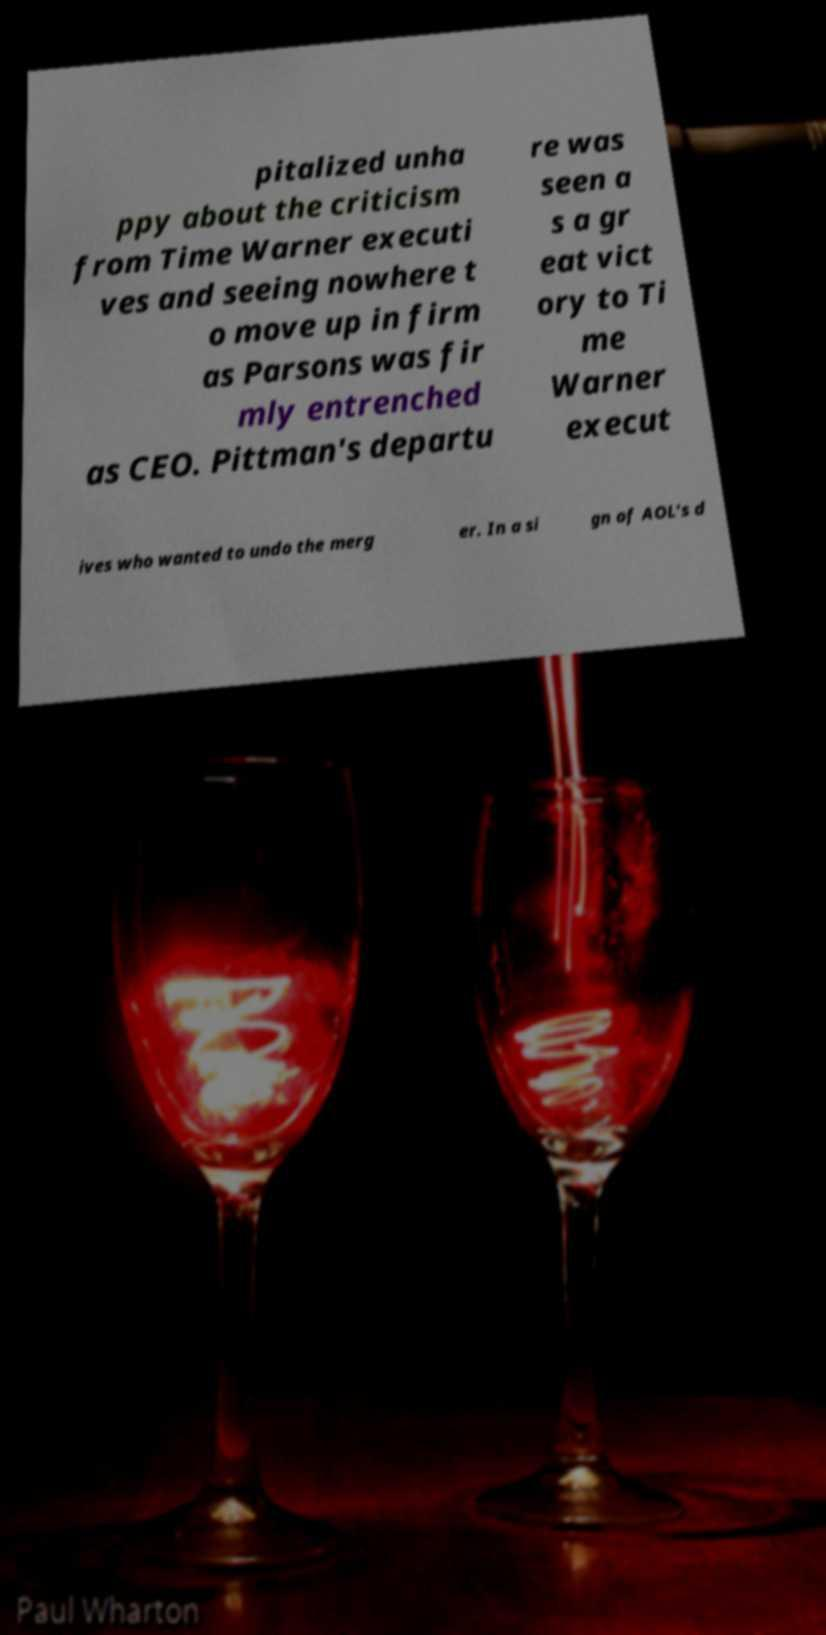Could you assist in decoding the text presented in this image and type it out clearly? pitalized unha ppy about the criticism from Time Warner executi ves and seeing nowhere t o move up in firm as Parsons was fir mly entrenched as CEO. Pittman's departu re was seen a s a gr eat vict ory to Ti me Warner execut ives who wanted to undo the merg er. In a si gn of AOL's d 